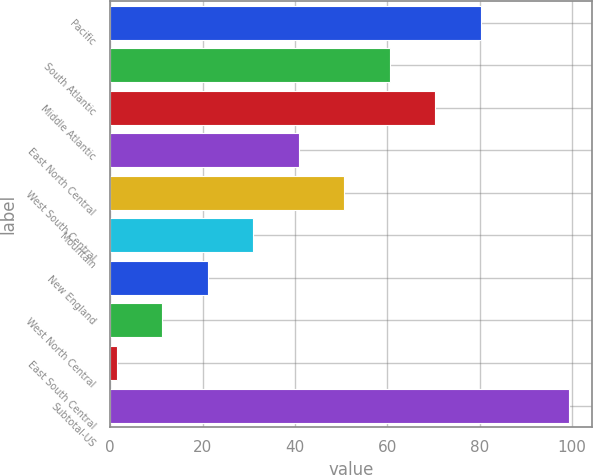<chart> <loc_0><loc_0><loc_500><loc_500><bar_chart><fcel>Pacific<fcel>South Atlantic<fcel>Middle Atlantic<fcel>East North Central<fcel>West South Central<fcel>Mountain<fcel>New England<fcel>West North Central<fcel>East South Central<fcel>Subtotal-US<nl><fcel>80.28<fcel>60.56<fcel>70.42<fcel>40.84<fcel>50.7<fcel>30.98<fcel>21.12<fcel>11.26<fcel>1.4<fcel>99.4<nl></chart> 